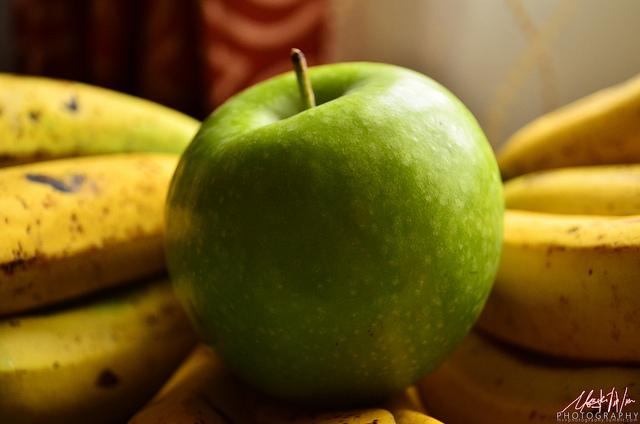What fruits are behind the apple?
Short answer required. Bananas. What fruit is pictured?
Write a very short answer. Apple. How many fruit is in the picture?
Keep it brief. 2. Is the green apple ready to eat?
Quick response, please. Yes. How many bananas are in the photo?
Give a very brief answer. 6. Is this apple tart?
Answer briefly. Yes. Is the apple sweating?
Give a very brief answer. No. What colors are the apples?
Keep it brief. Green. 